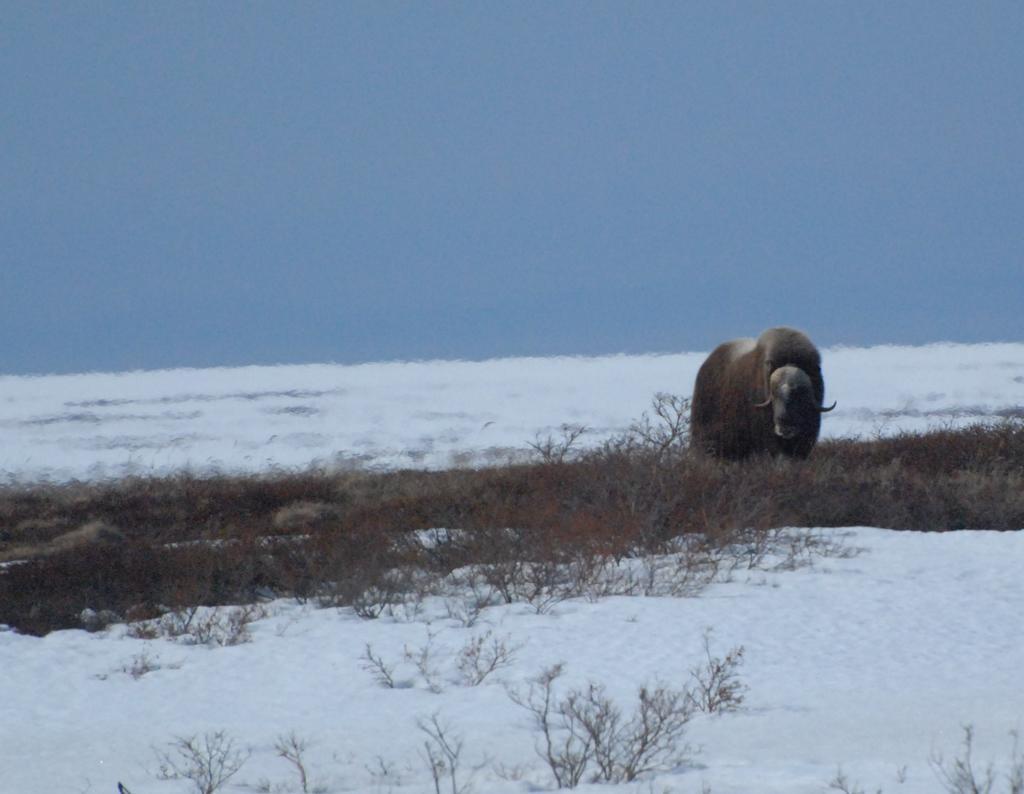Describe this image in one or two sentences. In this picture we can see an animal, snow and the grass and in the background we can see the sky. 